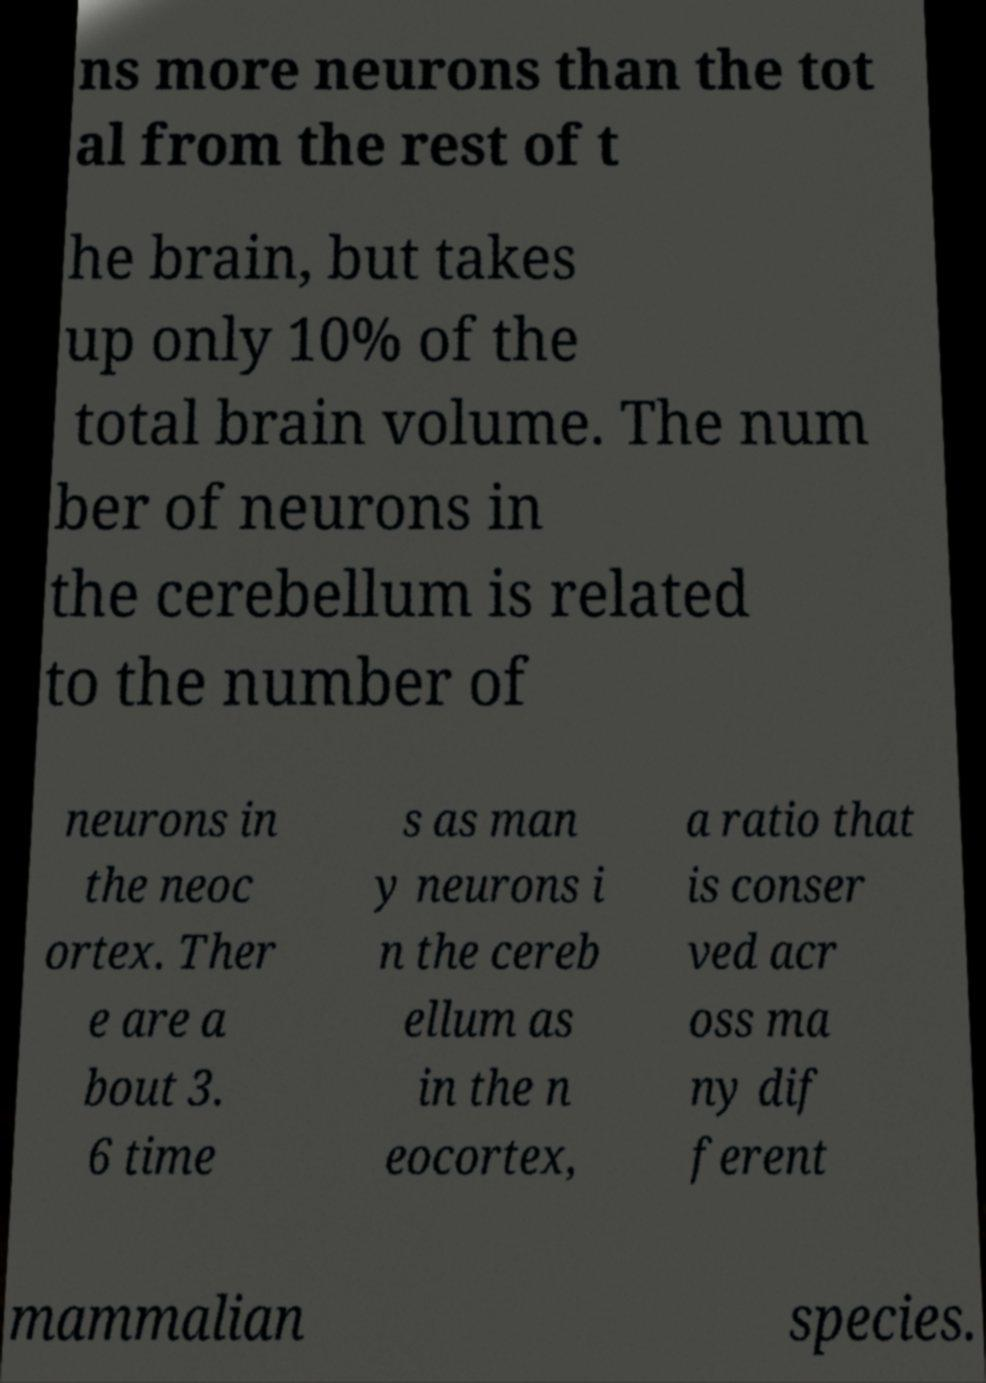Could you extract and type out the text from this image? ns more neurons than the tot al from the rest of t he brain, but takes up only 10% of the total brain volume. The num ber of neurons in the cerebellum is related to the number of neurons in the neoc ortex. Ther e are a bout 3. 6 time s as man y neurons i n the cereb ellum as in the n eocortex, a ratio that is conser ved acr oss ma ny dif ferent mammalian species. 